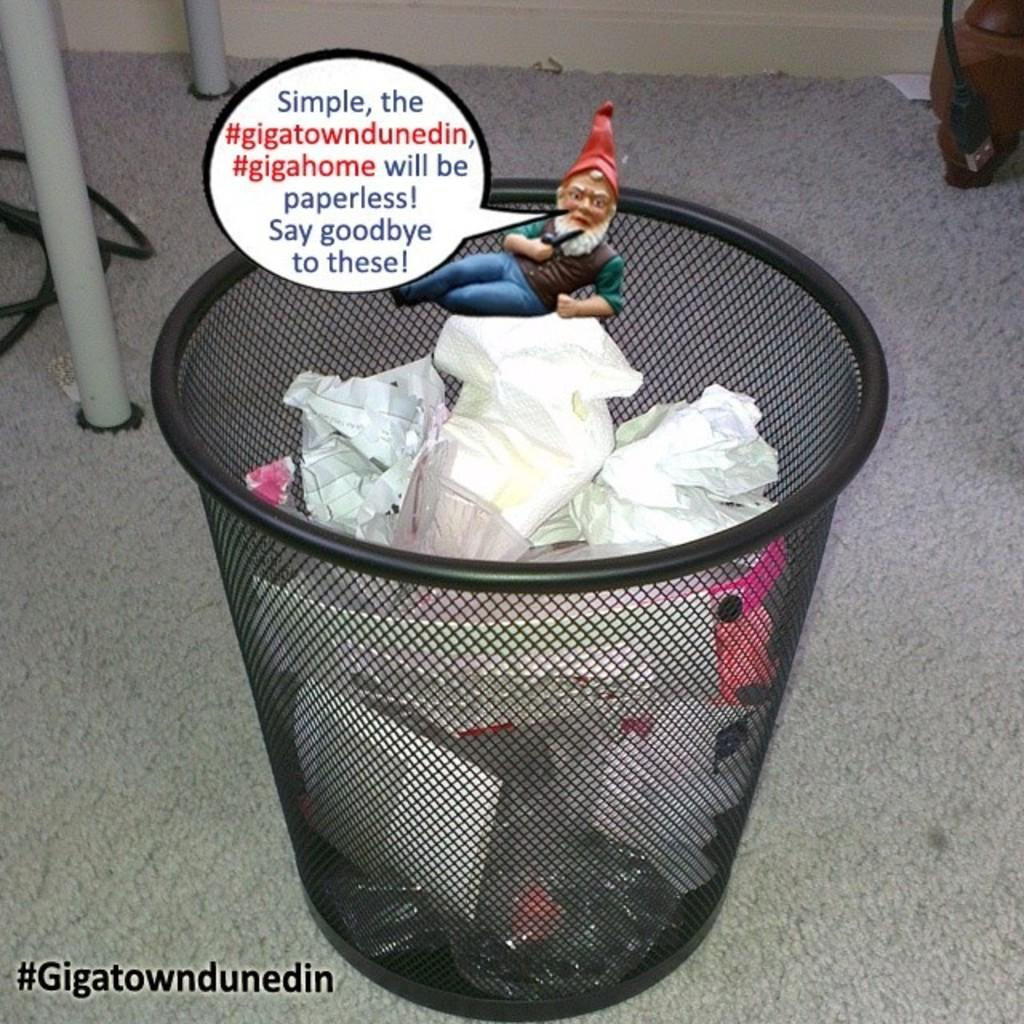<image>
Create a compact narrative representing the image presented. A toy gnome on a waste basket says a product will be paperless, making the waste basket papers obsolete. 